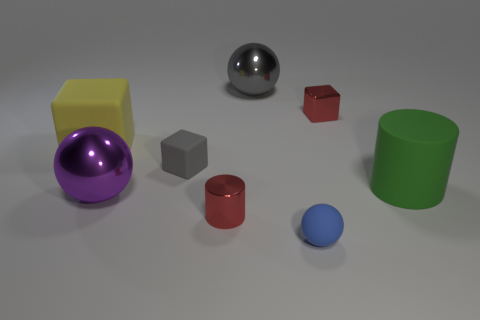Subtract all big balls. How many balls are left? 1 Subtract all gray blocks. How many blocks are left? 2 Subtract all balls. How many objects are left? 5 Subtract all cyan cylinders. How many red balls are left? 0 Subtract all big blue rubber blocks. Subtract all balls. How many objects are left? 5 Add 2 gray objects. How many gray objects are left? 4 Add 1 large rubber cubes. How many large rubber cubes exist? 2 Add 1 tiny purple metal balls. How many objects exist? 9 Subtract 1 gray cubes. How many objects are left? 7 Subtract 1 cylinders. How many cylinders are left? 1 